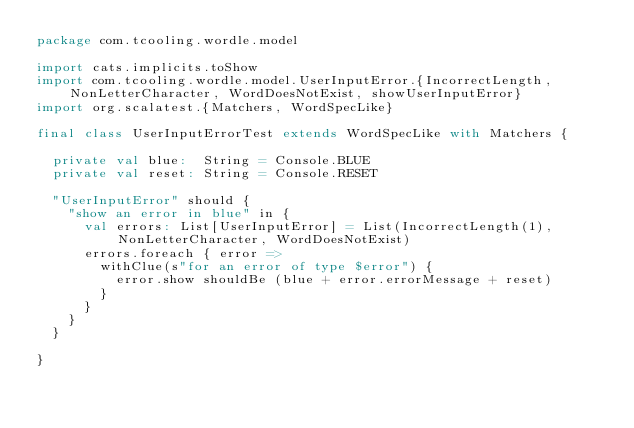<code> <loc_0><loc_0><loc_500><loc_500><_Scala_>package com.tcooling.wordle.model

import cats.implicits.toShow
import com.tcooling.wordle.model.UserInputError.{IncorrectLength, NonLetterCharacter, WordDoesNotExist, showUserInputError}
import org.scalatest.{Matchers, WordSpecLike}

final class UserInputErrorTest extends WordSpecLike with Matchers {

  private val blue:  String = Console.BLUE
  private val reset: String = Console.RESET

  "UserInputError" should {
    "show an error in blue" in {
      val errors: List[UserInputError] = List(IncorrectLength(1), NonLetterCharacter, WordDoesNotExist)
      errors.foreach { error =>
        withClue(s"for an error of type $error") {
          error.show shouldBe (blue + error.errorMessage + reset)
        }
      }
    }
  }

}
</code> 